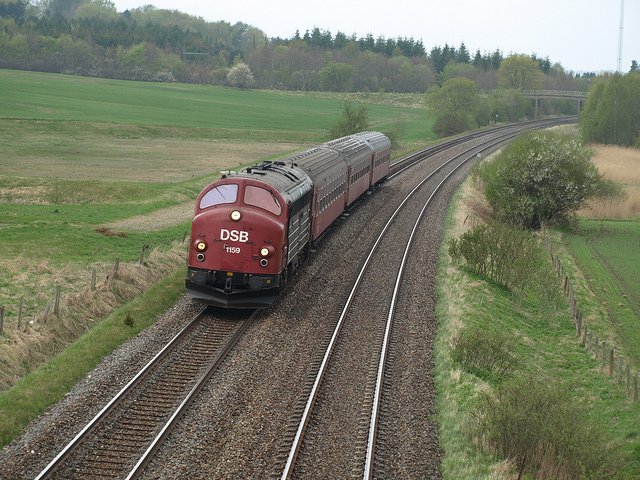Describe the setting of the image. The photo captures a rural or semi-rural landscape with a train moving along tracks that curve gently to the left. The background consists of open fields, a line of trees, and a fairly overcast sky, implying a quiet, perhaps early spring, day. What might this image suggest about the region's transportation? The presence of the train suggests that rail transport is a mode of travel or commodity transport in the region. The open countryside indicates that the railway connects different areas, likely going between more urban centers and rural locations. 